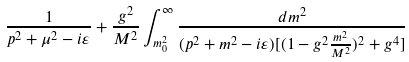Convert formula to latex. <formula><loc_0><loc_0><loc_500><loc_500>\frac { 1 } { p ^ { 2 } + \mu ^ { 2 } - i \varepsilon } + \frac { g ^ { 2 } } { M ^ { 2 } } \int _ { m _ { 0 } ^ { 2 } } ^ { \infty } \frac { d m ^ { 2 } } { ( p ^ { 2 } + m ^ { 2 } - i \varepsilon ) [ ( 1 - g ^ { 2 } \frac { m ^ { 2 } } { M ^ { 2 } } ) ^ { 2 } + g ^ { 4 } ] }</formula> 